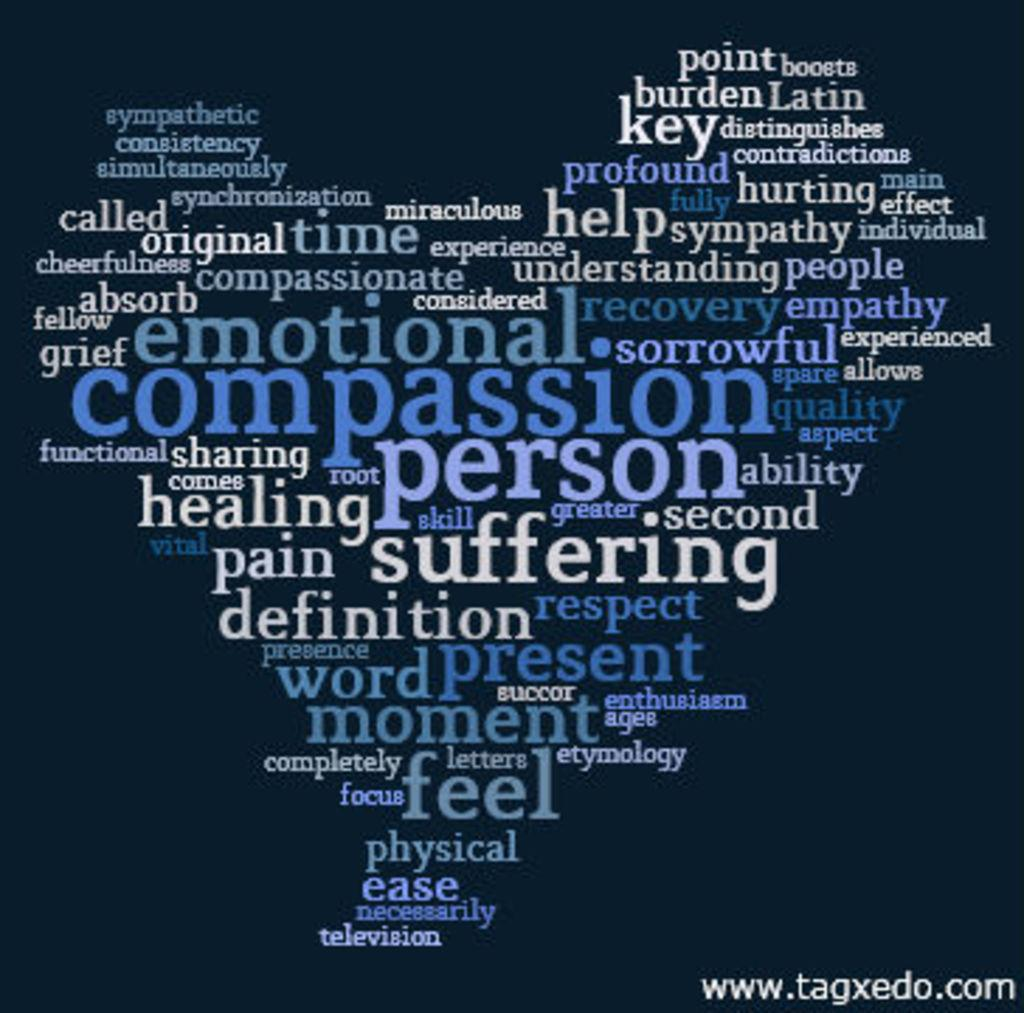<image>
Summarize the visual content of the image. A blue poster is covered with many words, including compassion, person, suffering, and feel. 